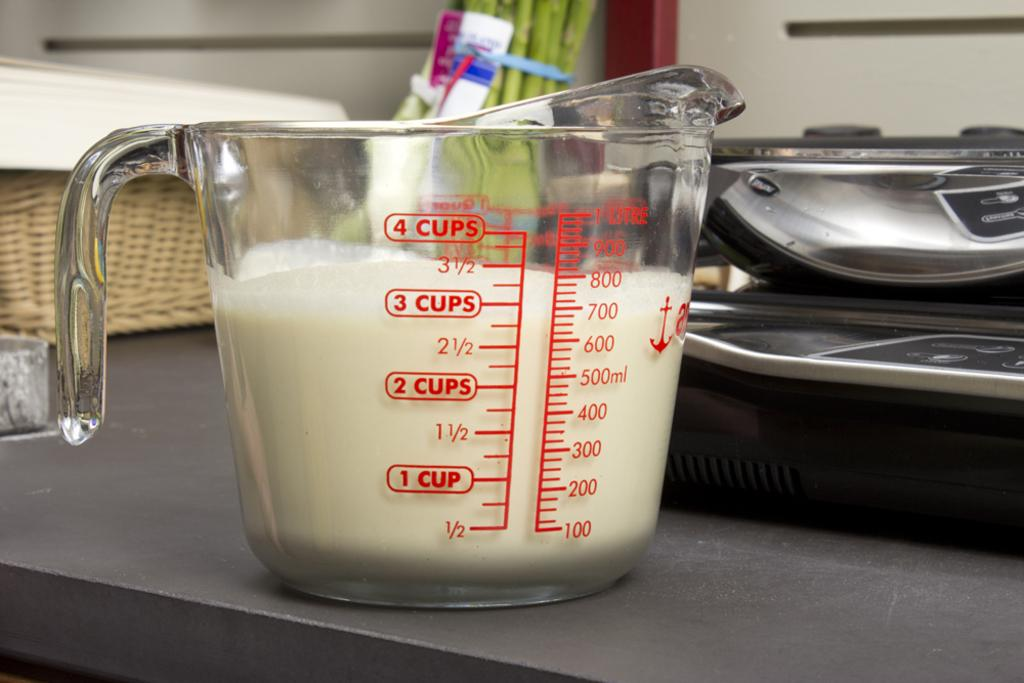What piece of furniture is present in the image? There is a table in the image. What can be seen on top of the table? There is a mug, a stove, a basket, food items, and some other objects on the table. Can you describe the stove on the table? The stove on the table is likely a small appliance used for cooking or heating food. What type of items are present in the basket on the table? The facts do not specify the contents of the basket, so we cannot determine what is inside. What type of grass is growing on the table in the image? There is no grass present in the image. 